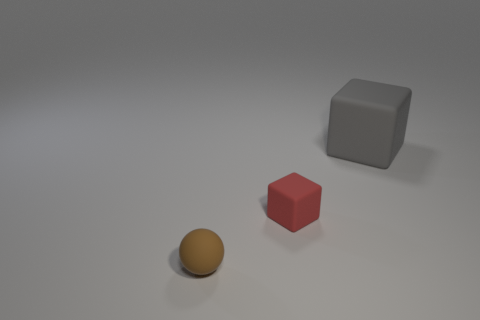There is a matte object that is both to the right of the small sphere and in front of the big rubber thing; what color is it?
Ensure brevity in your answer.  Red. Do the matte block to the left of the gray matte thing and the gray thing have the same size?
Keep it short and to the point. No. How many objects are either objects that are behind the small brown thing or large gray blocks?
Your response must be concise. 2. Are there any brown rubber objects of the same size as the red matte object?
Ensure brevity in your answer.  Yes. There is a cube that is the same size as the brown rubber sphere; what material is it?
Give a very brief answer. Rubber. There is a rubber object that is both on the right side of the small brown sphere and left of the gray rubber object; what shape is it?
Your answer should be compact. Cube. There is a small ball that is in front of the small matte block; what is its color?
Offer a terse response. Brown. There is a thing that is both behind the small brown ball and left of the large cube; how big is it?
Provide a succinct answer. Small. Do the red object and the small object left of the tiny rubber cube have the same material?
Make the answer very short. Yes. What number of other gray rubber objects have the same shape as the large gray object?
Keep it short and to the point. 0. 